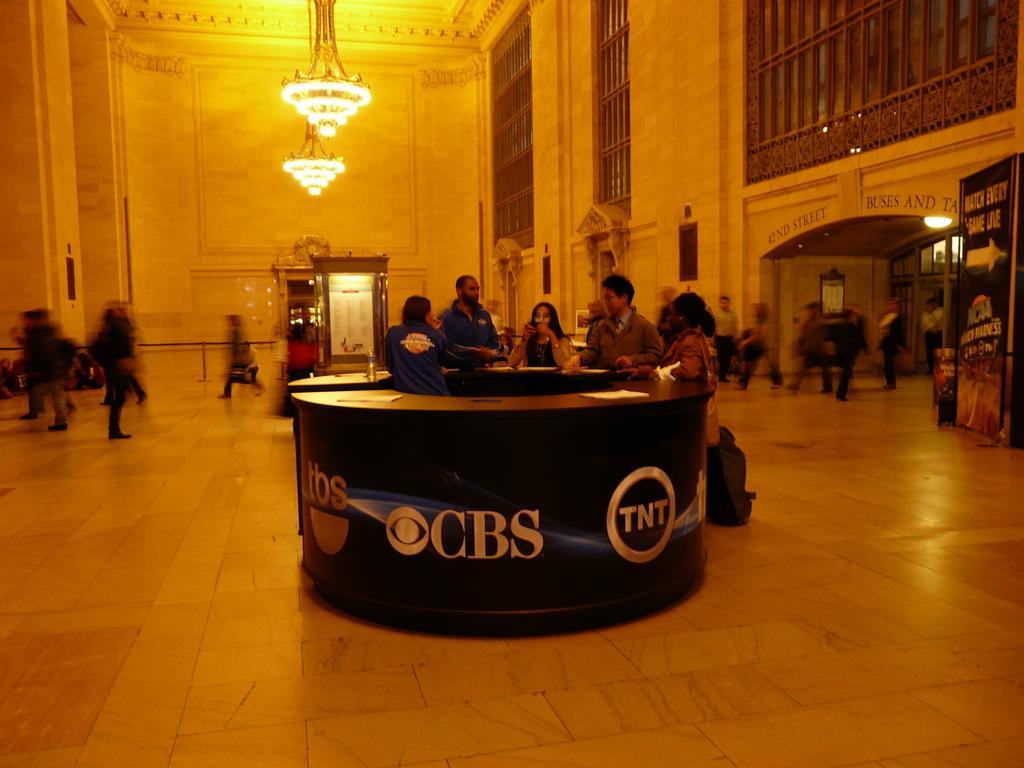In one or two sentences, can you explain what this image depicts? This is inside a building. In this building there are many people and there is a round stand. Near to that some people are standing. On the ceiling there are chandeliers. On the right side there is a wall and a banner. 